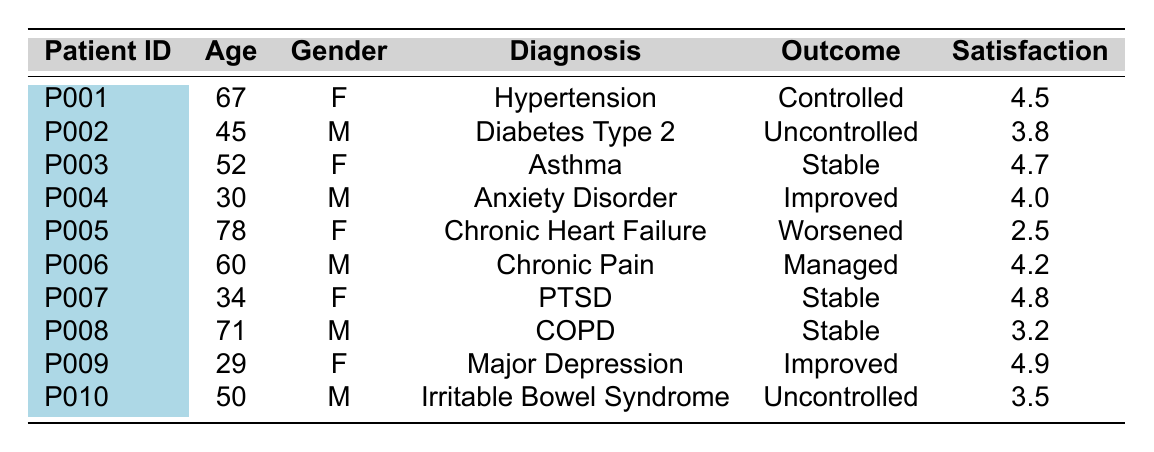What is the treatment outcome for patient P007? The table lists patient P007 with a treatment outcome of "Stable".
Answer: Stable How many patients have a satisfaction score greater than 4.5? Patients P003, P007, and P009 have satisfaction scores of 4.7, 4.8, and 4.9 respectively, making a total of 3 patients.
Answer: 3 What is the age of the patient with the diagnosis of Chronic Heart Failure? The table shows that the patient with Chronic Heart Failure (P005) is 78 years old.
Answer: 78 What is the average satisfaction score for all patients? The satisfaction scores are 4.5, 3.8, 4.7, 4.0, 2.5, 4.2, 4.8, 3.2, 4.9, and 3.5. Adding these gives a total of 44.1, divided by 10 patients results in an average score of 4.41.
Answer: 4.41 Is there any patient aged under 30? The table lists patient P009 at 29 years old, confirming that there is a patient under 30.
Answer: Yes Which gender has the highest satisfaction score among patients? The maximum satisfaction scores are 4.9 for a female patient (P009) and 4.8 for another female patient (P007). The highest satisfaction score belongs to a female.
Answer: Female How many patients have an "Uncontrolled" treatment outcome? Patients P002 and P010 both have an "Uncontrolled" outcome, totaling 2 patients.
Answer: 2 What is the most common diagnosis among the patients? The diagnoses are varied with no duplicates; however, certain diagnoses may exist among others, but can be listed as Hypertension (1), Diabetes Type 2 (1), etc. Therefore, each is unique in this dataset.
Answer: No common diagnosis How many patients are from a rural location who had a "Worsened" treatment outcome? Only patient P005 is identified from a rural area with a "Worsened" outcome.
Answer: 1 What is the difference in age between the oldest and youngest patients? The oldest patient is P005 at 78 years old and the youngest is P009 at 29 years old. The difference is 78 - 29 = 49 years.
Answer: 49 